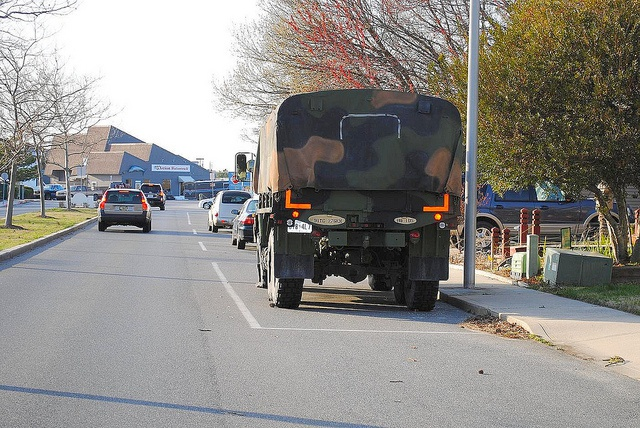Describe the objects in this image and their specific colors. I can see truck in darkgray, black, gray, and purple tones, truck in darkgray, black, gray, and navy tones, car in darkgray, black, gray, and navy tones, car in darkgray, white, and gray tones, and car in darkgray, black, lightgray, and gray tones in this image. 